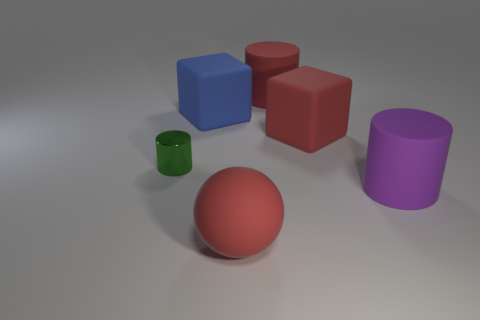Subtract all red matte cylinders. How many cylinders are left? 2 Add 2 blue cubes. How many objects exist? 8 Subtract all green cylinders. How many cylinders are left? 2 Subtract 1 balls. How many balls are left? 0 Subtract all cubes. How many objects are left? 4 Subtract all green metallic balls. Subtract all metallic things. How many objects are left? 5 Add 4 cylinders. How many cylinders are left? 7 Add 4 red matte balls. How many red matte balls exist? 5 Subtract 0 gray cubes. How many objects are left? 6 Subtract all yellow cylinders. Subtract all red balls. How many cylinders are left? 3 